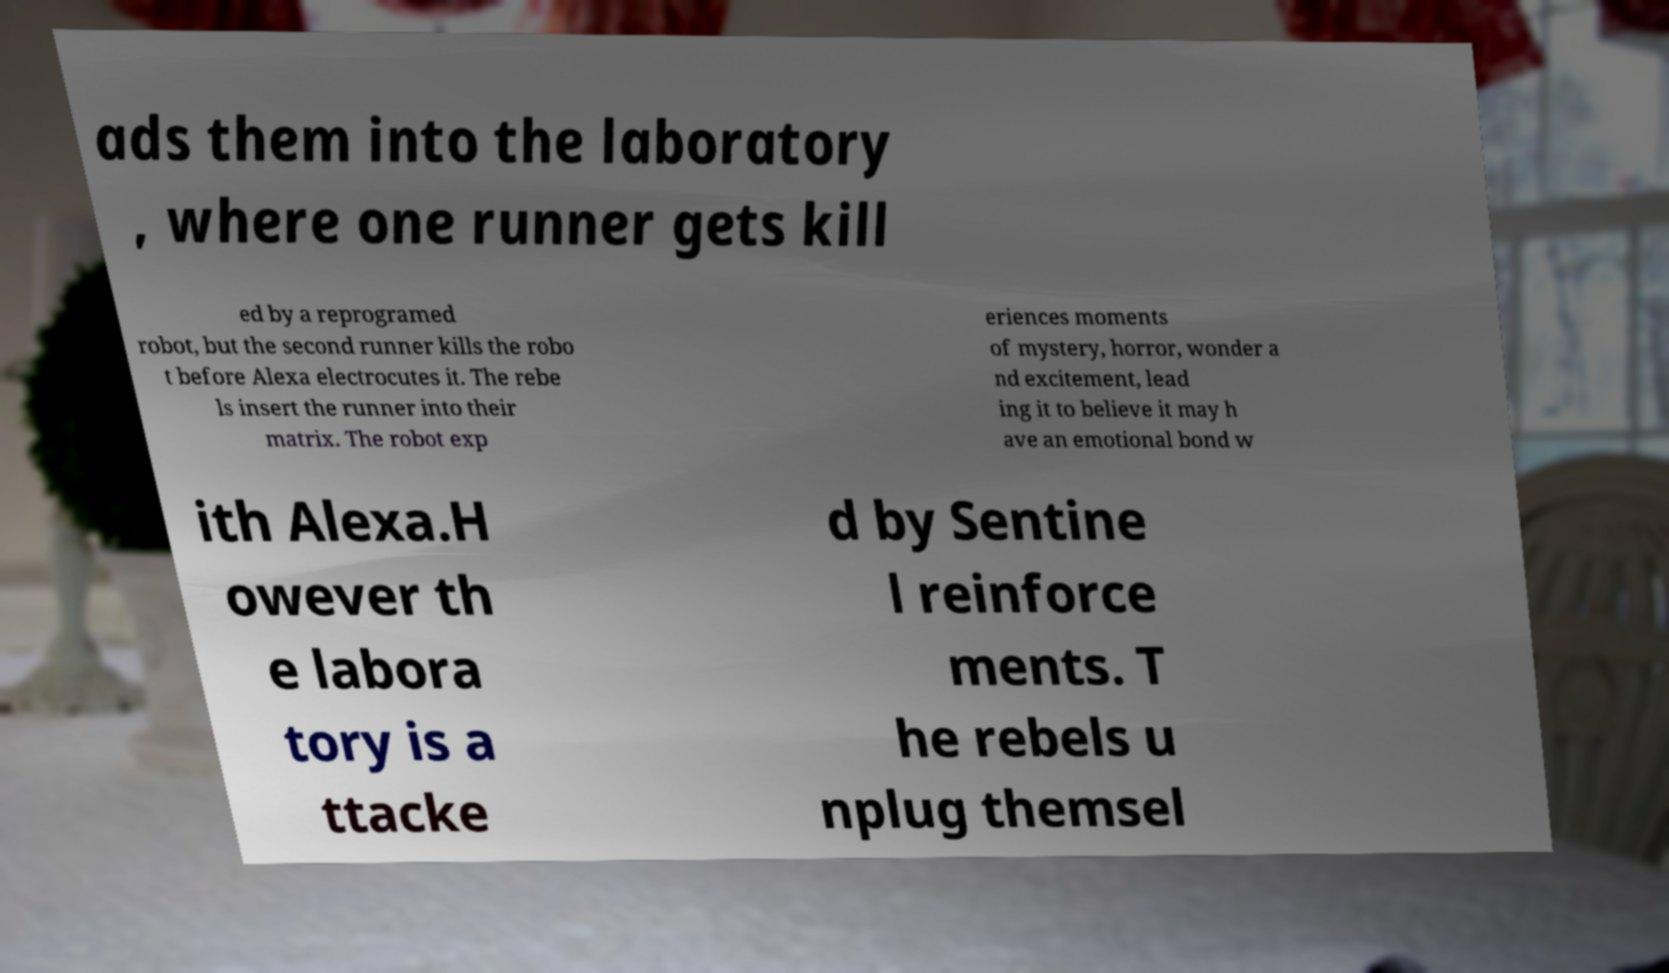Can you accurately transcribe the text from the provided image for me? ads them into the laboratory , where one runner gets kill ed by a reprogramed robot, but the second runner kills the robo t before Alexa electrocutes it. The rebe ls insert the runner into their matrix. The robot exp eriences moments of mystery, horror, wonder a nd excitement, lead ing it to believe it may h ave an emotional bond w ith Alexa.H owever th e labora tory is a ttacke d by Sentine l reinforce ments. T he rebels u nplug themsel 